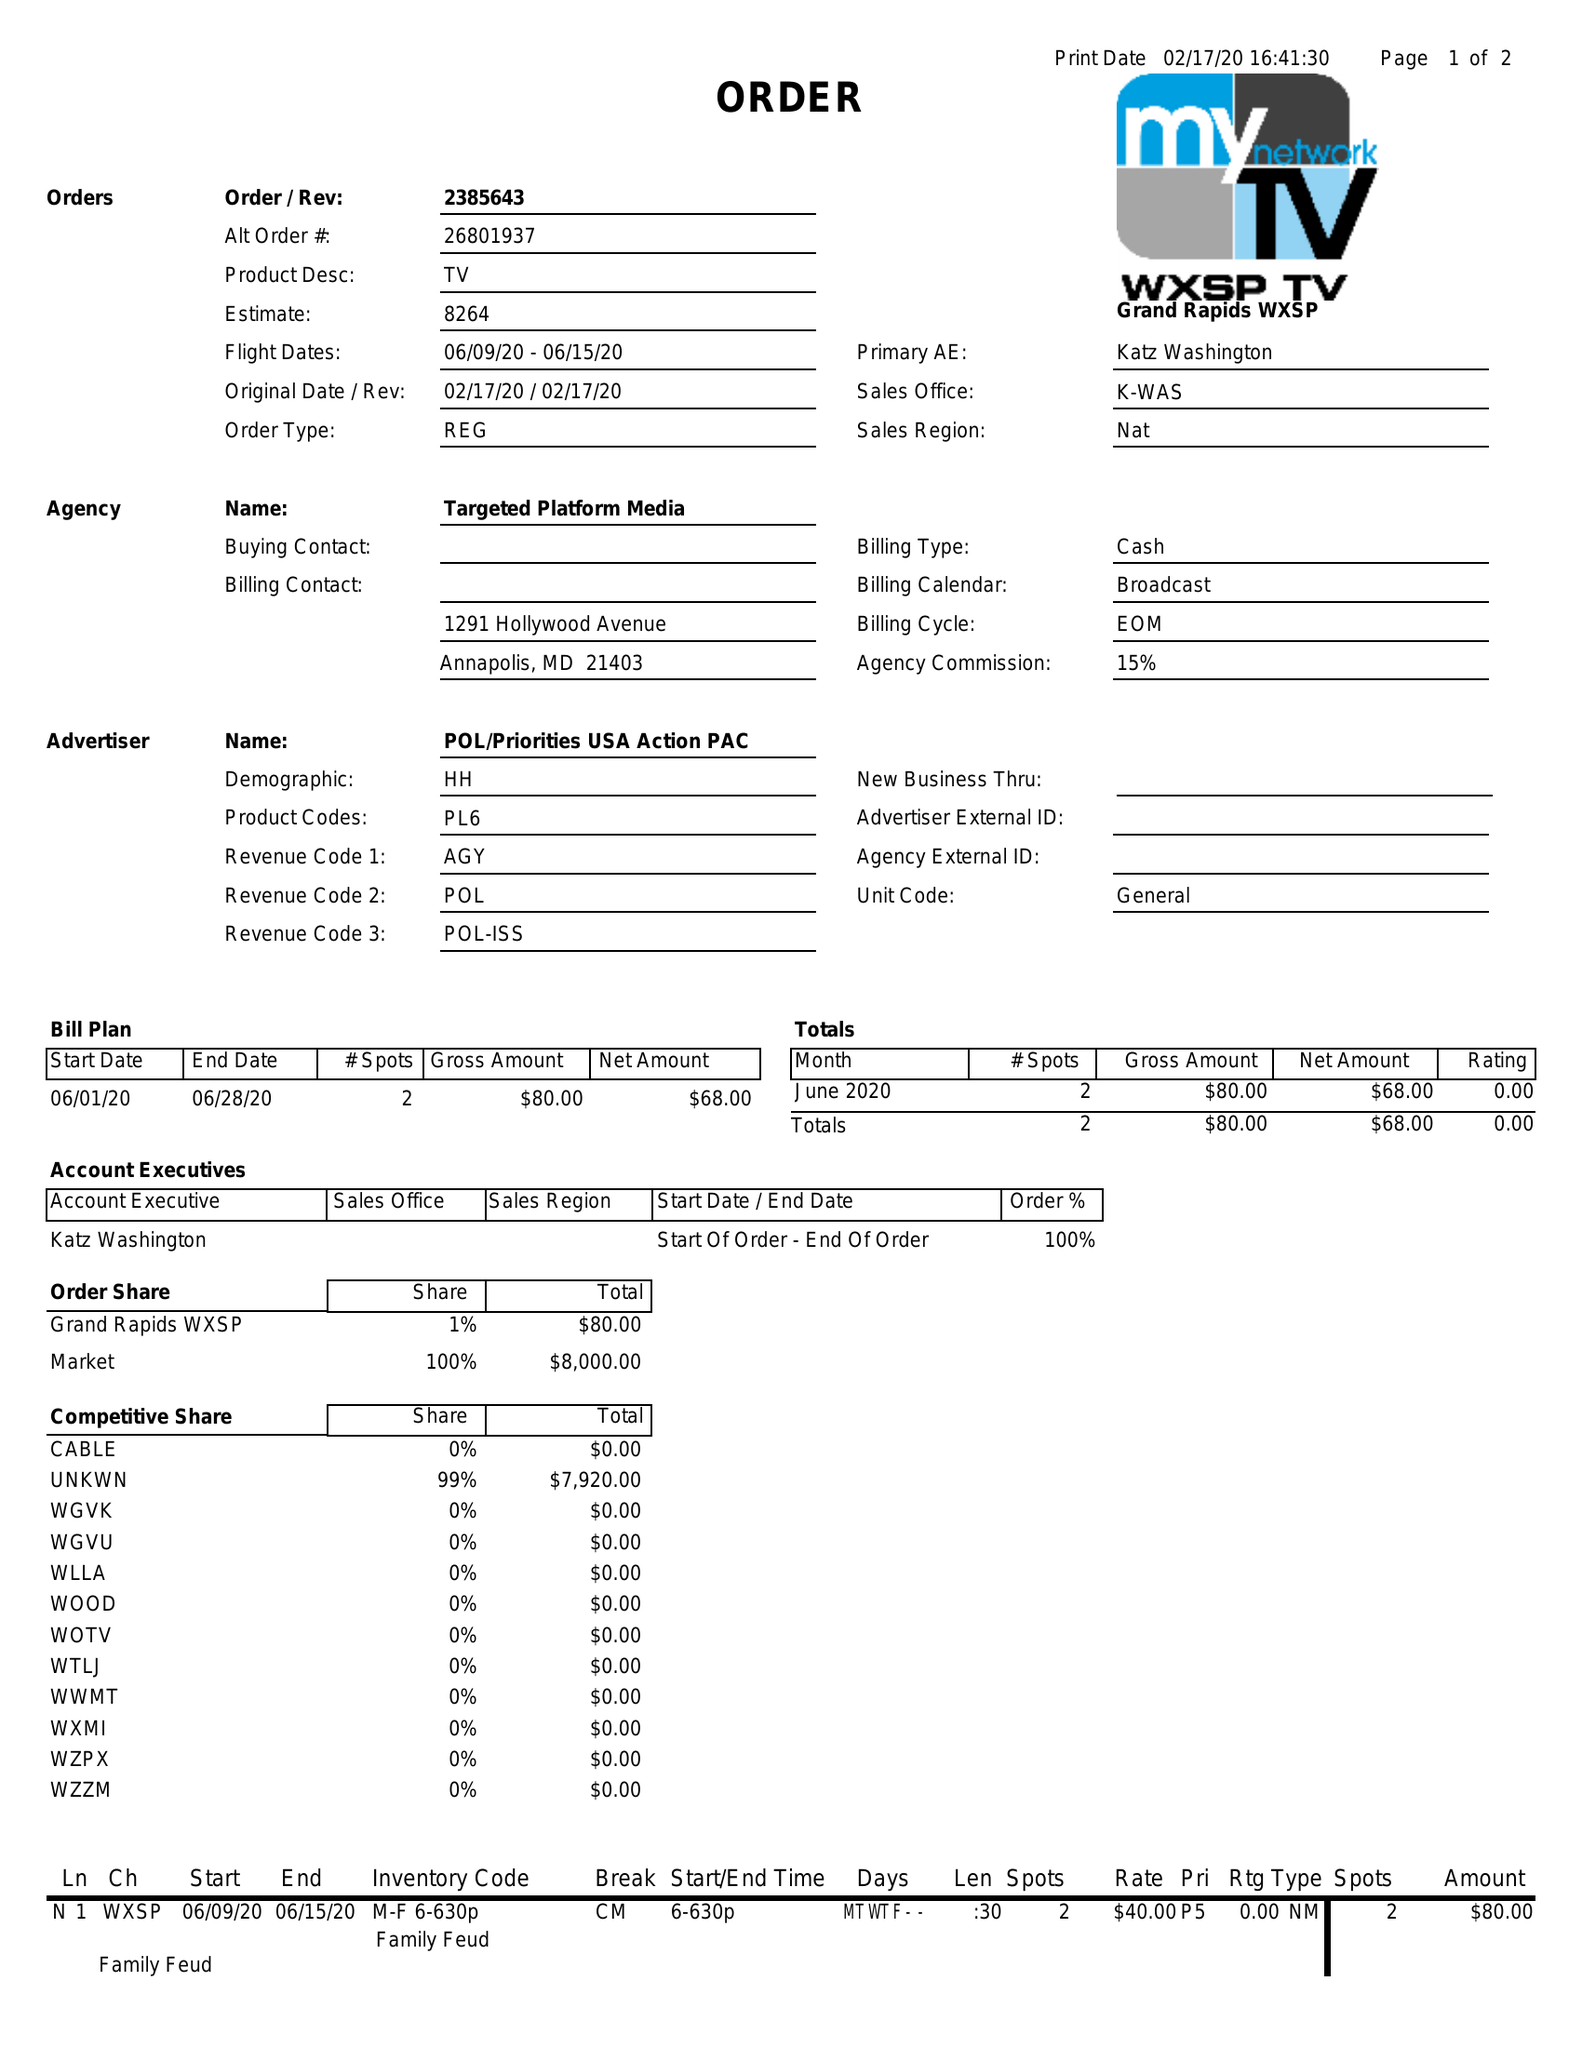What is the value for the flight_to?
Answer the question using a single word or phrase. 06/15/20 